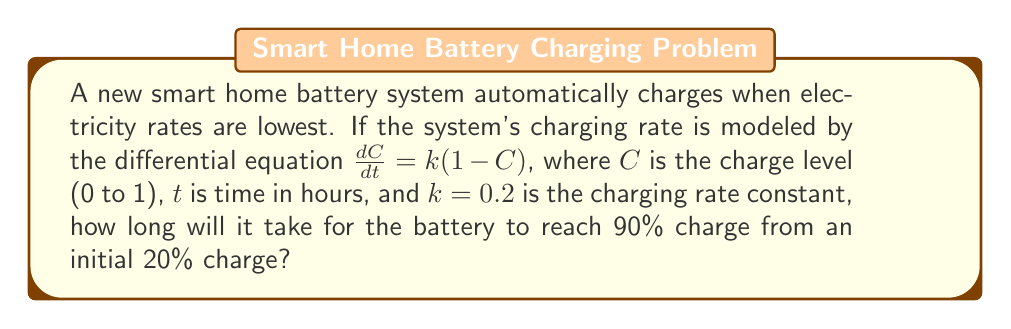Help me with this question. To solve this problem, we'll follow these steps:

1) The given differential equation is $\frac{dC}{dt} = k(1-C)$ with $k=0.2$.

2) This is a separable differential equation. We can solve it as follows:

   $\frac{dC}{1-C} = k dt$

3) Integrating both sides:

   $-\ln(1-C) = kt + A$, where $A$ is a constant of integration

4) Solving for $C$:

   $C = 1 - e^{-(kt+A)} = 1 - Be^{-kt}$, where $B = e^{-A}$

5) We can find $B$ using the initial condition. At $t=0$, $C=0.2$:

   $0.2 = 1 - Be^{-0} = 1 - B$
   $B = 0.8$

6) So our solution is:

   $C = 1 - 0.8e^{-0.2t}$

7) We want to find $t$ when $C=0.9$. Substituting:

   $0.9 = 1 - 0.8e^{-0.2t}$

8) Solving for $t$:

   $0.8e^{-0.2t} = 0.1$
   $e^{-0.2t} = 0.125$
   $-0.2t = \ln(0.125)$
   $t = -\frac{\ln(0.125)}{0.2} \approx 10.4$ hours

Therefore, it will take approximately 10.4 hours for the battery to reach 90% charge from an initial 20% charge.
Answer: 10.4 hours 